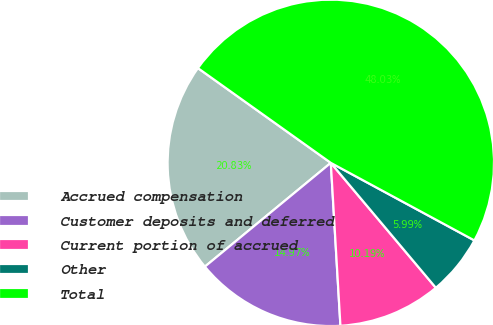<chart> <loc_0><loc_0><loc_500><loc_500><pie_chart><fcel>Accrued compensation<fcel>Customer deposits and deferred<fcel>Current portion of accrued<fcel>Other<fcel>Total<nl><fcel>20.83%<fcel>14.97%<fcel>10.19%<fcel>5.99%<fcel>48.03%<nl></chart> 